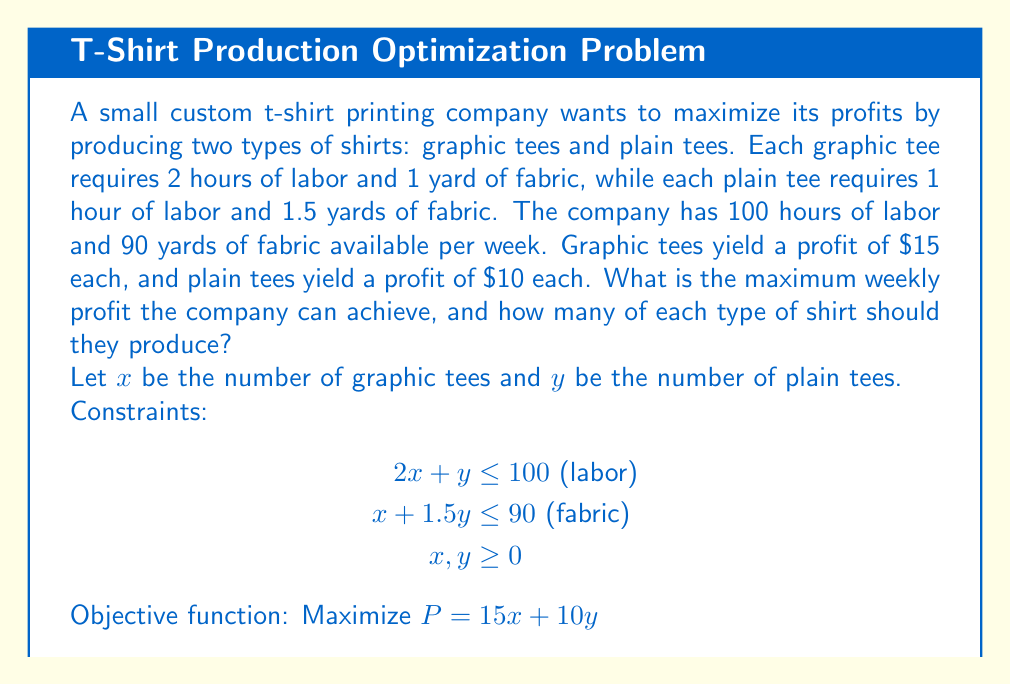Teach me how to tackle this problem. To solve this linear programming problem, we'll use the graphical method:

1. Plot the constraints:
   a) $2x + y = 100$
   b) $x + 1.5y = 90$
   c) $x = 0$ and $y = 0$ (non-negativity constraints)

2. Identify the feasible region (the area that satisfies all constraints).

3. Find the corner points of the feasible region:
   - $(0, 0)$
   - $(0, 60)$ (intersection of $y$-axis and $x + 1.5y = 90$)
   - $(45, 10)$ (intersection of $2x + y = 100$ and $x + 1.5y = 90$)
   - $(50, 0)$ (intersection of $x$-axis and $2x + y = 100$)

4. Evaluate the objective function at each corner point:
   - $P(0, 0) = 0$
   - $P(0, 60) = 10(60) = 600$
   - $P(45, 10) = 15(45) + 10(10) = 775$
   - $P(50, 0) = 15(50) = 750$

5. The maximum profit occurs at the point $(45, 10)$, which gives:
   - 45 graphic tees
   - 10 plain tees
   - Maximum profit: $775

[asy]
import geometry;

size(200);
xaxis("x", 0, 60);
yaxis("y", 0, 80);

draw((0,100)--(50,0), blue);
draw((0,60)--(90,0), red);

fill((0,0)--(0,60)--(45,10)--(50,0)--cycle, palegreen+opacity(0.2));

dot((0,0));
dot((0,60));
dot((45,10));
dot((50,0));

label("(0,0)", (0,0), SW);
label("(0,60)", (0,60), NW);
label("(45,10)", (45,10), NE);
label("(50,0)", (50,0), SE);

label("2x + y = 100", (25,50), NW, blue);
label("x + 1.5y = 90", (45,30), SE, red);
[/asy]
Answer: 45 graphic tees, 10 plain tees; $775 maximum profit 